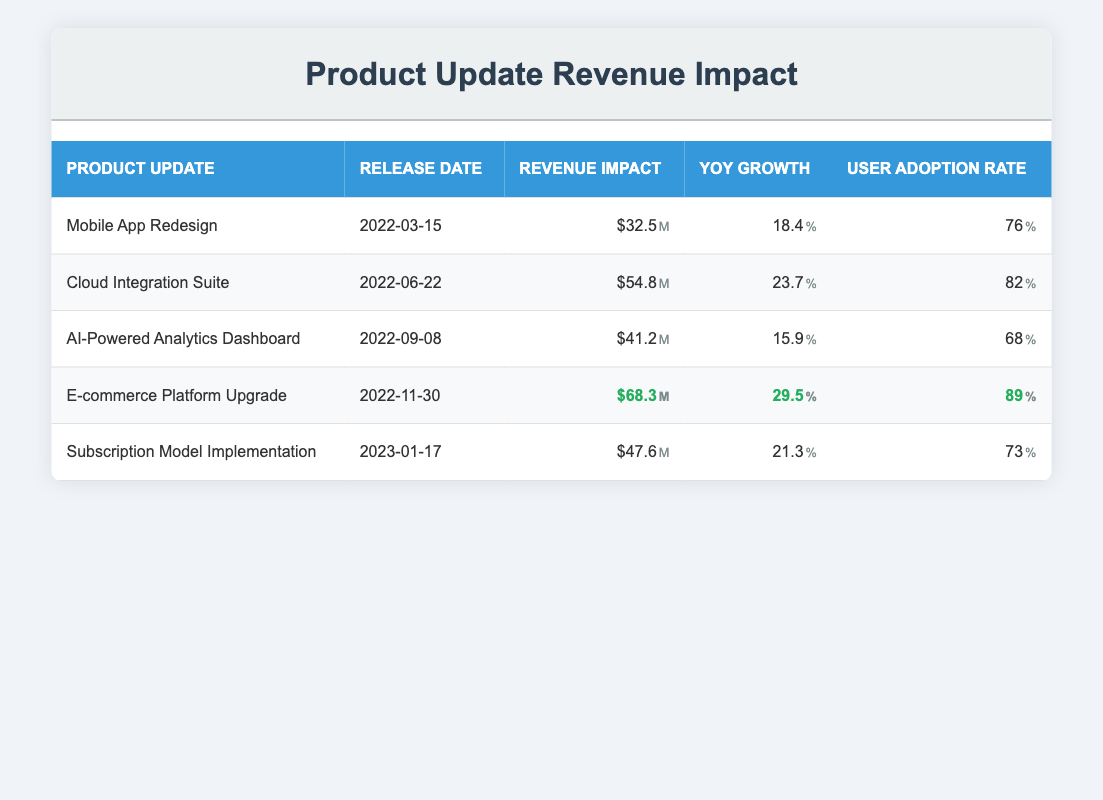What was the revenue impact of the E-commerce Platform Upgrade? The table shows that the revenue impact for the E-commerce Platform Upgrade is $68.3 million.
Answer: $68.3 million Which product update had the highest user adoption rate? Looking at the table, the E-commerce Platform Upgrade has the highest user adoption rate at 89%.
Answer: 89% What is the average revenue impact of all product updates? To find the average, we sum up the revenue impacts: 32.5 + 54.8 + 41.2 + 68.3 + 47.6 = 244.4. There are 5 updates, so the average is 244.4 / 5 = 48.88.
Answer: 48.88 million Did the AI-Powered Analytics Dashboard have a higher YoY growth than the Mobile App Redesign? The YoY growth for the AI-Powered Analytics Dashboard is 15.9% while for the Mobile App Redesign it is 18.4%. Since 15.9% is less than 18.4%, the statement is false.
Answer: No What is the total revenue impact from the first two product updates? The revenue impact of the first two updates, Mobile App Redesign ($32.5 million) and Cloud Integration Suite ($54.8 million), sums up to 32.5 + 54.8 = 87.3 million.
Answer: 87.3 million Which product update was released latest, and what was its revenue impact? The latest product update listed is the Subscription Model Implementation released on January 17, 2023, with a revenue impact of $47.6 million.
Answer: Subscription Model Implementation, $47.6 million Is the user adoption rate for the Subscription Model Implementation higher than the Cloud Integration Suite? The user adoption rate for Subscription Model Implementation is 73% while for Cloud Integration Suite it is 82%. Since 73% is less than 82%, the answer is no.
Answer: No How much revenue impact did the Cloud Integration Suite have compared to the average revenue impact? The Cloud Integration Suite had a revenue impact of $54.8 million, while the average revenue impact is 48.88 million. 54.8 is greater than 48.88, so we conclude it had a higher impact.
Answer: Higher 